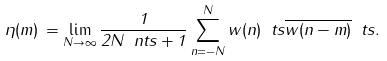<formula> <loc_0><loc_0><loc_500><loc_500>\eta ( m ) \, = \lim _ { N \to \infty } \frac { 1 } { 2 N \ n t s + 1 } \sum _ { n = - N } ^ { N } w ( n ) \ t s \overline { w ( n - m ) } \ t s .</formula> 